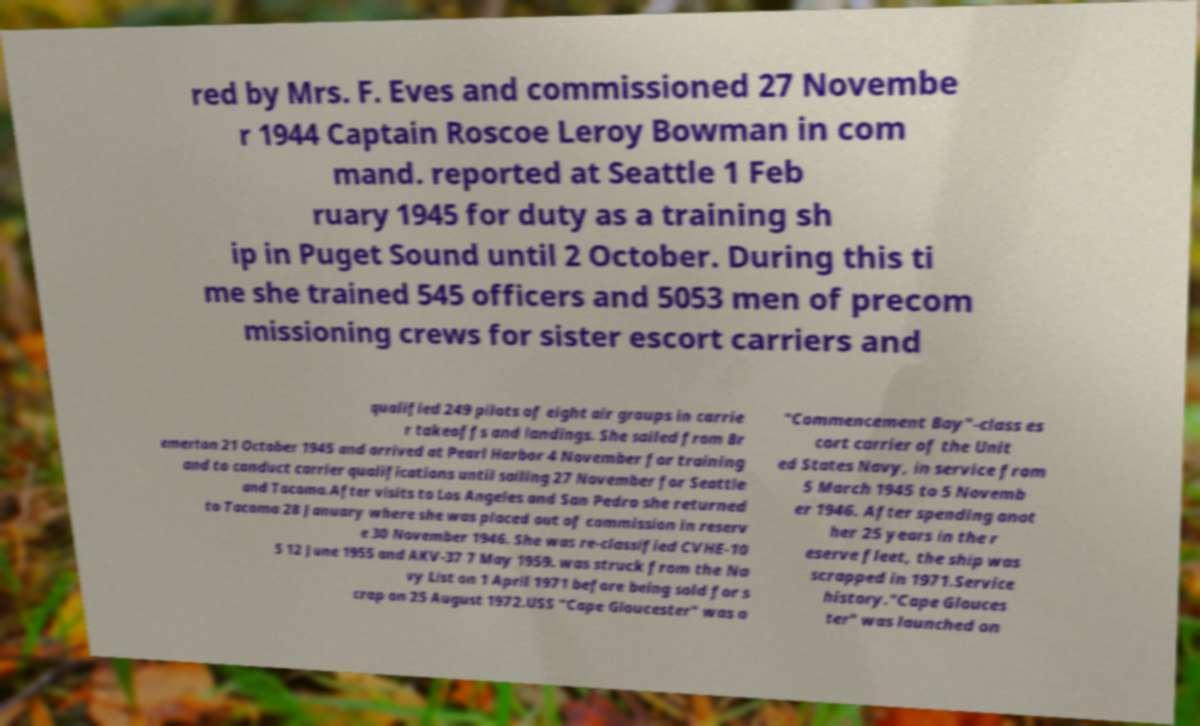I need the written content from this picture converted into text. Can you do that? red by Mrs. F. Eves and commissioned 27 Novembe r 1944 Captain Roscoe Leroy Bowman in com mand. reported at Seattle 1 Feb ruary 1945 for duty as a training sh ip in Puget Sound until 2 October. During this ti me she trained 545 officers and 5053 men of precom missioning crews for sister escort carriers and qualified 249 pilots of eight air groups in carrie r takeoffs and landings. She sailed from Br emerton 21 October 1945 and arrived at Pearl Harbor 4 November for training and to conduct carrier qualifications until sailing 27 November for Seattle and Tacoma.After visits to Los Angeles and San Pedro she returned to Tacoma 28 January where she was placed out of commission in reserv e 30 November 1946. She was re-classified CVHE-10 5 12 June 1955 and AKV-37 7 May 1959. was struck from the Na vy List on 1 April 1971 before being sold for s crap on 25 August 1972.USS "Cape Gloucester" was a "Commencement Bay"-class es cort carrier of the Unit ed States Navy, in service from 5 March 1945 to 5 Novemb er 1946. After spending anot her 25 years in the r eserve fleet, the ship was scrapped in 1971.Service history."Cape Glouces ter" was launched on 